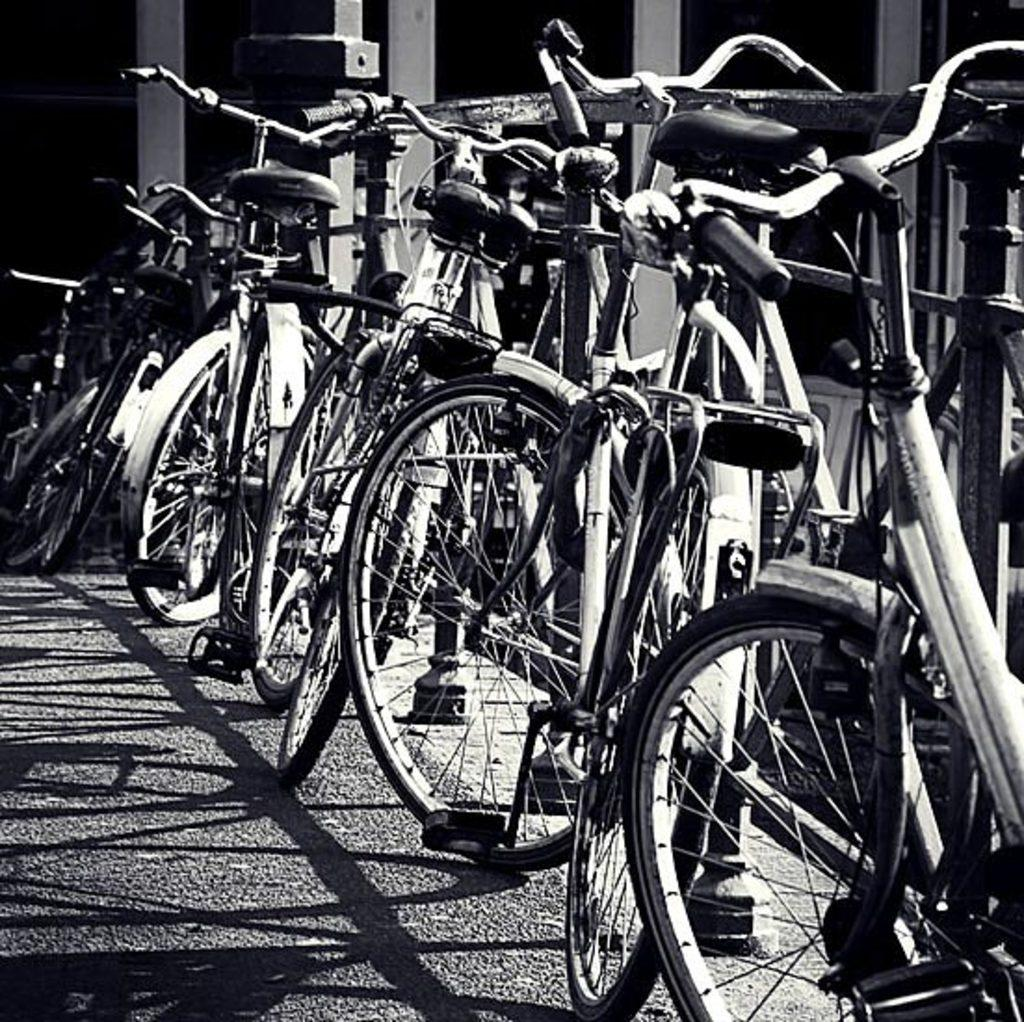What objects are on the ground in the image? There are bicycles on the ground in the image. What type of barrier can be seen in the image? There is a fence visible in the image. What color scheme is used in the image? The image is black and white in color. Can you see anyone making a request in the image? There is no indication of anyone making a request in the image. Is anyone driving a vehicle in the image? There are no vehicles present in the image, so no one is driving. What type of vegetable can be seen in the image? There are no vegetables, including celery, present in the image. 